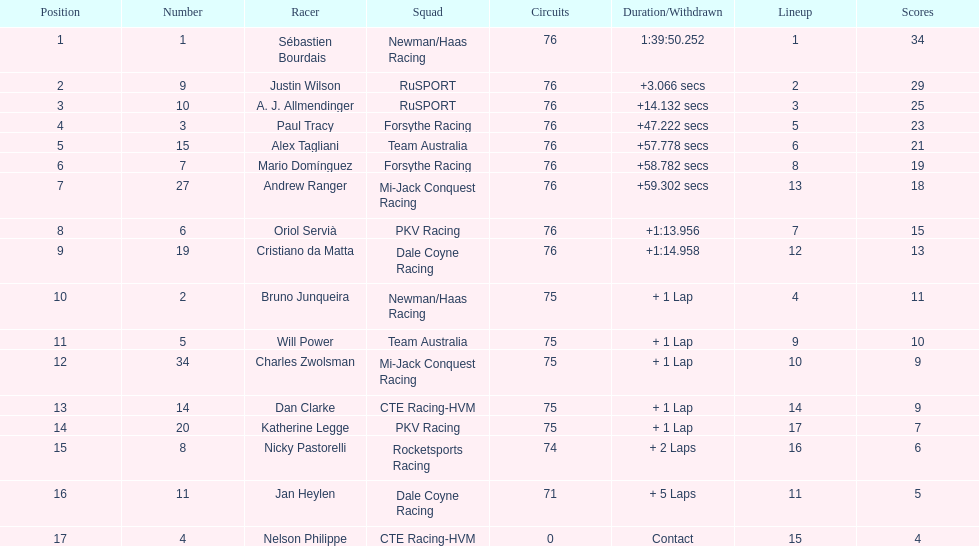Which driver earned the least amount of points. Nelson Philippe. 